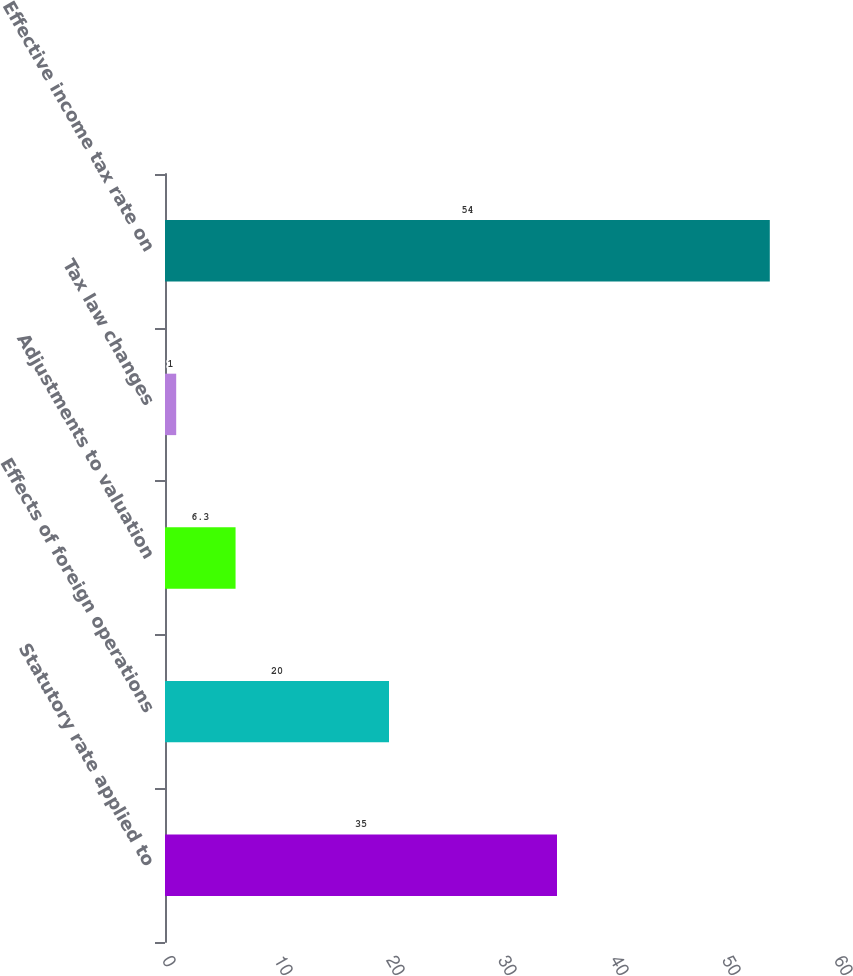Convert chart to OTSL. <chart><loc_0><loc_0><loc_500><loc_500><bar_chart><fcel>Statutory rate applied to<fcel>Effects of foreign operations<fcel>Adjustments to valuation<fcel>Tax law changes<fcel>Effective income tax rate on<nl><fcel>35<fcel>20<fcel>6.3<fcel>1<fcel>54<nl></chart> 